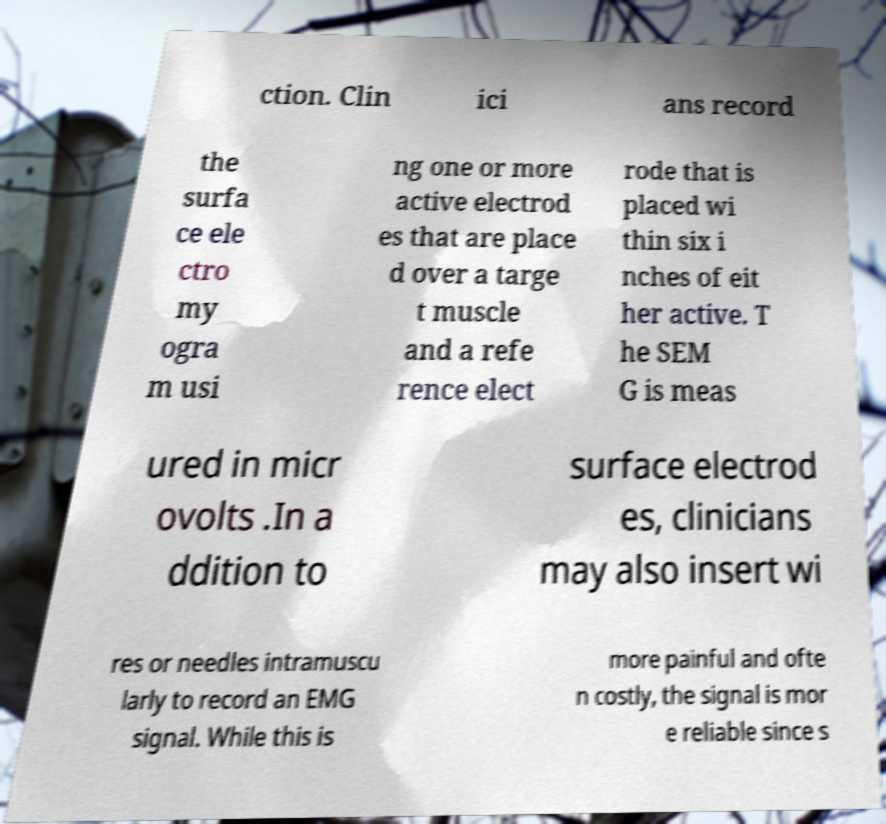Could you extract and type out the text from this image? ction. Clin ici ans record the surfa ce ele ctro my ogra m usi ng one or more active electrod es that are place d over a targe t muscle and a refe rence elect rode that is placed wi thin six i nches of eit her active. T he SEM G is meas ured in micr ovolts .In a ddition to surface electrod es, clinicians may also insert wi res or needles intramuscu larly to record an EMG signal. While this is more painful and ofte n costly, the signal is mor e reliable since s 